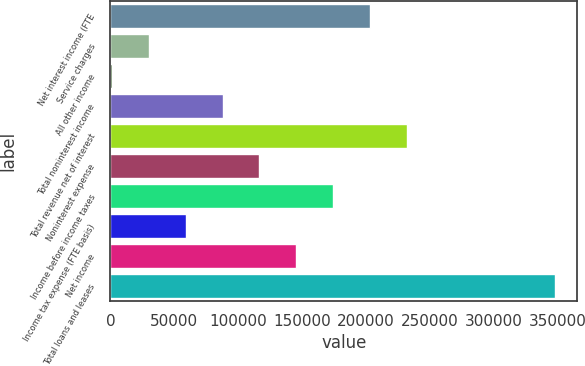Convert chart to OTSL. <chart><loc_0><loc_0><loc_500><loc_500><bar_chart><fcel>Net interest income (FTE<fcel>Service charges<fcel>All other income<fcel>Total noninterest income<fcel>Total revenue net of interest<fcel>Noninterest expense<fcel>Income before income taxes<fcel>Income tax expense (FTE basis)<fcel>Net income<fcel>Total loans and leases<nl><fcel>203323<fcel>30000.2<fcel>1113<fcel>87774.6<fcel>232211<fcel>116662<fcel>174436<fcel>58887.4<fcel>145549<fcel>347759<nl></chart> 